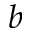Convert formula to latex. <formula><loc_0><loc_0><loc_500><loc_500>b</formula> 